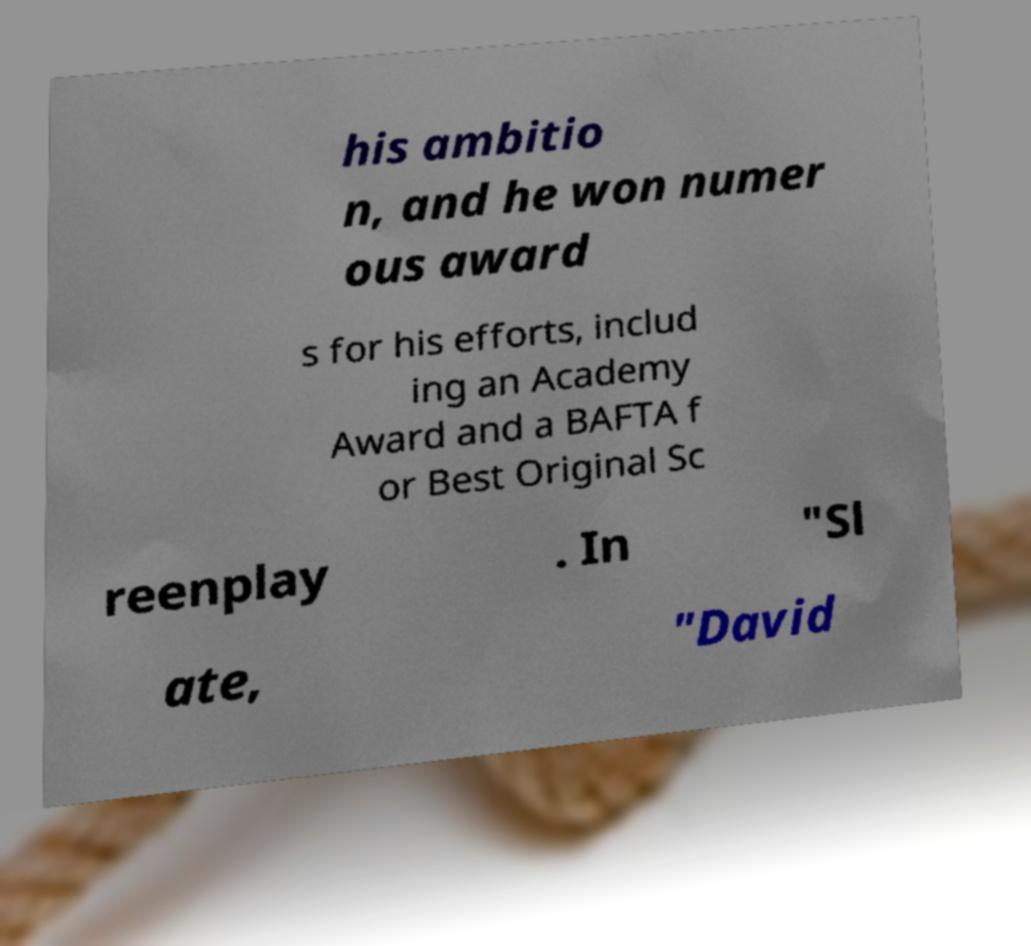For documentation purposes, I need the text within this image transcribed. Could you provide that? his ambitio n, and he won numer ous award s for his efforts, includ ing an Academy Award and a BAFTA f or Best Original Sc reenplay . In "Sl ate, "David 